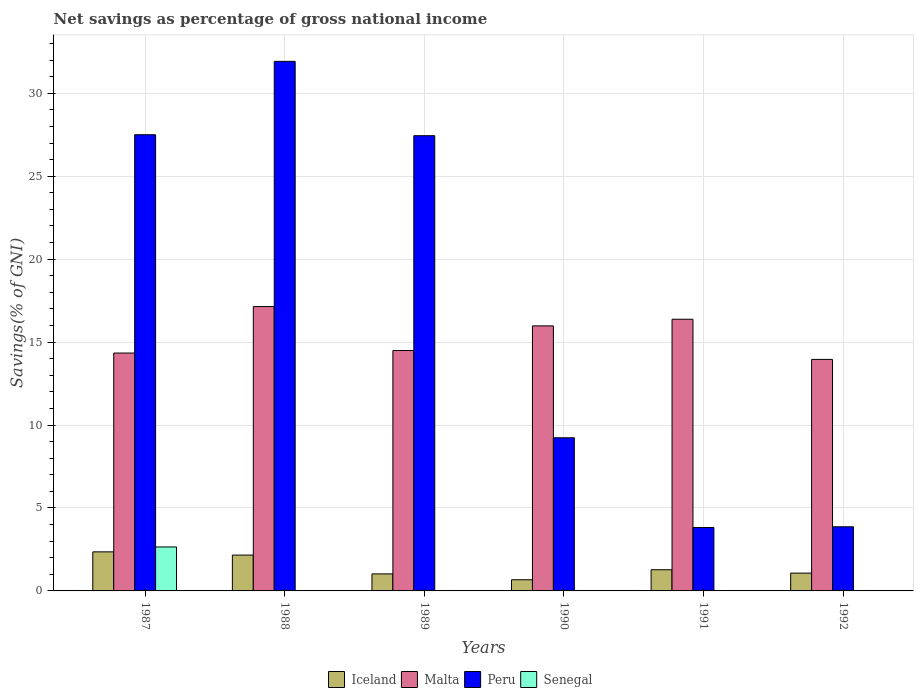How many different coloured bars are there?
Your response must be concise. 4. How many groups of bars are there?
Offer a terse response. 6. Are the number of bars per tick equal to the number of legend labels?
Make the answer very short. No. Are the number of bars on each tick of the X-axis equal?
Offer a very short reply. No. How many bars are there on the 4th tick from the left?
Offer a very short reply. 3. How many bars are there on the 5th tick from the right?
Your answer should be very brief. 3. What is the label of the 3rd group of bars from the left?
Offer a terse response. 1989. What is the total savings in Iceland in 1990?
Your response must be concise. 0.67. Across all years, what is the maximum total savings in Senegal?
Keep it short and to the point. 2.65. Across all years, what is the minimum total savings in Peru?
Your answer should be very brief. 3.82. What is the total total savings in Senegal in the graph?
Offer a terse response. 2.65. What is the difference between the total savings in Malta in 1989 and that in 1990?
Provide a succinct answer. -1.49. What is the difference between the total savings in Senegal in 1988 and the total savings in Peru in 1992?
Offer a very short reply. -3.87. What is the average total savings in Iceland per year?
Give a very brief answer. 1.43. In the year 1988, what is the difference between the total savings in Iceland and total savings in Peru?
Provide a succinct answer. -29.76. What is the ratio of the total savings in Malta in 1987 to that in 1989?
Your answer should be very brief. 0.99. Is the difference between the total savings in Iceland in 1990 and 1992 greater than the difference between the total savings in Peru in 1990 and 1992?
Provide a succinct answer. No. What is the difference between the highest and the second highest total savings in Peru?
Keep it short and to the point. 4.42. What is the difference between the highest and the lowest total savings in Malta?
Your response must be concise. 3.19. Is the sum of the total savings in Malta in 1990 and 1992 greater than the maximum total savings in Senegal across all years?
Make the answer very short. Yes. How many bars are there?
Offer a terse response. 19. What is the difference between two consecutive major ticks on the Y-axis?
Your answer should be very brief. 5. Are the values on the major ticks of Y-axis written in scientific E-notation?
Your response must be concise. No. Does the graph contain any zero values?
Offer a very short reply. Yes. How many legend labels are there?
Keep it short and to the point. 4. What is the title of the graph?
Your answer should be compact. Net savings as percentage of gross national income. Does "Guatemala" appear as one of the legend labels in the graph?
Your answer should be compact. No. What is the label or title of the X-axis?
Ensure brevity in your answer.  Years. What is the label or title of the Y-axis?
Make the answer very short. Savings(% of GNI). What is the Savings(% of GNI) in Iceland in 1987?
Your response must be concise. 2.36. What is the Savings(% of GNI) in Malta in 1987?
Your answer should be compact. 14.34. What is the Savings(% of GNI) in Peru in 1987?
Provide a short and direct response. 27.5. What is the Savings(% of GNI) in Senegal in 1987?
Provide a short and direct response. 2.65. What is the Savings(% of GNI) in Iceland in 1988?
Make the answer very short. 2.16. What is the Savings(% of GNI) of Malta in 1988?
Your response must be concise. 17.14. What is the Savings(% of GNI) in Peru in 1988?
Ensure brevity in your answer.  31.92. What is the Savings(% of GNI) in Senegal in 1988?
Provide a succinct answer. 0. What is the Savings(% of GNI) in Iceland in 1989?
Your answer should be very brief. 1.03. What is the Savings(% of GNI) in Malta in 1989?
Your answer should be compact. 14.49. What is the Savings(% of GNI) of Peru in 1989?
Provide a short and direct response. 27.44. What is the Savings(% of GNI) of Senegal in 1989?
Provide a succinct answer. 0. What is the Savings(% of GNI) of Iceland in 1990?
Make the answer very short. 0.67. What is the Savings(% of GNI) of Malta in 1990?
Your answer should be very brief. 15.98. What is the Savings(% of GNI) of Peru in 1990?
Ensure brevity in your answer.  9.23. What is the Savings(% of GNI) in Iceland in 1991?
Offer a terse response. 1.28. What is the Savings(% of GNI) of Malta in 1991?
Provide a succinct answer. 16.38. What is the Savings(% of GNI) in Peru in 1991?
Your answer should be compact. 3.82. What is the Savings(% of GNI) in Senegal in 1991?
Your answer should be compact. 0. What is the Savings(% of GNI) in Iceland in 1992?
Ensure brevity in your answer.  1.07. What is the Savings(% of GNI) of Malta in 1992?
Ensure brevity in your answer.  13.96. What is the Savings(% of GNI) in Peru in 1992?
Make the answer very short. 3.87. Across all years, what is the maximum Savings(% of GNI) in Iceland?
Provide a succinct answer. 2.36. Across all years, what is the maximum Savings(% of GNI) of Malta?
Make the answer very short. 17.14. Across all years, what is the maximum Savings(% of GNI) of Peru?
Your answer should be very brief. 31.92. Across all years, what is the maximum Savings(% of GNI) of Senegal?
Offer a very short reply. 2.65. Across all years, what is the minimum Savings(% of GNI) in Iceland?
Your response must be concise. 0.67. Across all years, what is the minimum Savings(% of GNI) in Malta?
Give a very brief answer. 13.96. Across all years, what is the minimum Savings(% of GNI) in Peru?
Ensure brevity in your answer.  3.82. What is the total Savings(% of GNI) in Iceland in the graph?
Provide a succinct answer. 8.57. What is the total Savings(% of GNI) of Malta in the graph?
Offer a very short reply. 92.29. What is the total Savings(% of GNI) in Peru in the graph?
Keep it short and to the point. 103.79. What is the total Savings(% of GNI) in Senegal in the graph?
Your response must be concise. 2.65. What is the difference between the Savings(% of GNI) of Iceland in 1987 and that in 1988?
Give a very brief answer. 0.2. What is the difference between the Savings(% of GNI) of Malta in 1987 and that in 1988?
Your answer should be very brief. -2.8. What is the difference between the Savings(% of GNI) of Peru in 1987 and that in 1988?
Offer a very short reply. -4.42. What is the difference between the Savings(% of GNI) of Iceland in 1987 and that in 1989?
Your answer should be compact. 1.33. What is the difference between the Savings(% of GNI) of Malta in 1987 and that in 1989?
Offer a very short reply. -0.15. What is the difference between the Savings(% of GNI) in Peru in 1987 and that in 1989?
Offer a very short reply. 0.06. What is the difference between the Savings(% of GNI) of Iceland in 1987 and that in 1990?
Offer a very short reply. 1.68. What is the difference between the Savings(% of GNI) in Malta in 1987 and that in 1990?
Your answer should be compact. -1.64. What is the difference between the Savings(% of GNI) in Peru in 1987 and that in 1990?
Your answer should be compact. 18.27. What is the difference between the Savings(% of GNI) in Iceland in 1987 and that in 1991?
Your response must be concise. 1.08. What is the difference between the Savings(% of GNI) of Malta in 1987 and that in 1991?
Provide a succinct answer. -2.04. What is the difference between the Savings(% of GNI) of Peru in 1987 and that in 1991?
Your response must be concise. 23.68. What is the difference between the Savings(% of GNI) in Iceland in 1987 and that in 1992?
Offer a terse response. 1.28. What is the difference between the Savings(% of GNI) in Malta in 1987 and that in 1992?
Offer a very short reply. 0.38. What is the difference between the Savings(% of GNI) of Peru in 1987 and that in 1992?
Keep it short and to the point. 23.64. What is the difference between the Savings(% of GNI) in Iceland in 1988 and that in 1989?
Offer a terse response. 1.13. What is the difference between the Savings(% of GNI) in Malta in 1988 and that in 1989?
Your response must be concise. 2.65. What is the difference between the Savings(% of GNI) of Peru in 1988 and that in 1989?
Offer a terse response. 4.48. What is the difference between the Savings(% of GNI) in Iceland in 1988 and that in 1990?
Make the answer very short. 1.49. What is the difference between the Savings(% of GNI) in Malta in 1988 and that in 1990?
Offer a terse response. 1.17. What is the difference between the Savings(% of GNI) of Peru in 1988 and that in 1990?
Your answer should be compact. 22.69. What is the difference between the Savings(% of GNI) in Iceland in 1988 and that in 1991?
Your answer should be compact. 0.88. What is the difference between the Savings(% of GNI) in Malta in 1988 and that in 1991?
Keep it short and to the point. 0.76. What is the difference between the Savings(% of GNI) of Peru in 1988 and that in 1991?
Ensure brevity in your answer.  28.1. What is the difference between the Savings(% of GNI) of Iceland in 1988 and that in 1992?
Make the answer very short. 1.09. What is the difference between the Savings(% of GNI) of Malta in 1988 and that in 1992?
Give a very brief answer. 3.19. What is the difference between the Savings(% of GNI) in Peru in 1988 and that in 1992?
Give a very brief answer. 28.06. What is the difference between the Savings(% of GNI) of Iceland in 1989 and that in 1990?
Make the answer very short. 0.35. What is the difference between the Savings(% of GNI) of Malta in 1989 and that in 1990?
Ensure brevity in your answer.  -1.49. What is the difference between the Savings(% of GNI) of Peru in 1989 and that in 1990?
Your answer should be compact. 18.21. What is the difference between the Savings(% of GNI) in Iceland in 1989 and that in 1991?
Your answer should be compact. -0.25. What is the difference between the Savings(% of GNI) of Malta in 1989 and that in 1991?
Your answer should be very brief. -1.89. What is the difference between the Savings(% of GNI) of Peru in 1989 and that in 1991?
Offer a very short reply. 23.62. What is the difference between the Savings(% of GNI) of Iceland in 1989 and that in 1992?
Your answer should be compact. -0.05. What is the difference between the Savings(% of GNI) in Malta in 1989 and that in 1992?
Provide a succinct answer. 0.54. What is the difference between the Savings(% of GNI) of Peru in 1989 and that in 1992?
Give a very brief answer. 23.58. What is the difference between the Savings(% of GNI) in Iceland in 1990 and that in 1991?
Make the answer very short. -0.6. What is the difference between the Savings(% of GNI) in Malta in 1990 and that in 1991?
Provide a short and direct response. -0.4. What is the difference between the Savings(% of GNI) of Peru in 1990 and that in 1991?
Offer a terse response. 5.41. What is the difference between the Savings(% of GNI) in Iceland in 1990 and that in 1992?
Give a very brief answer. -0.4. What is the difference between the Savings(% of GNI) in Malta in 1990 and that in 1992?
Ensure brevity in your answer.  2.02. What is the difference between the Savings(% of GNI) of Peru in 1990 and that in 1992?
Make the answer very short. 5.36. What is the difference between the Savings(% of GNI) in Iceland in 1991 and that in 1992?
Offer a terse response. 0.2. What is the difference between the Savings(% of GNI) of Malta in 1991 and that in 1992?
Offer a terse response. 2.42. What is the difference between the Savings(% of GNI) of Peru in 1991 and that in 1992?
Ensure brevity in your answer.  -0.04. What is the difference between the Savings(% of GNI) of Iceland in 1987 and the Savings(% of GNI) of Malta in 1988?
Offer a very short reply. -14.79. What is the difference between the Savings(% of GNI) in Iceland in 1987 and the Savings(% of GNI) in Peru in 1988?
Provide a succinct answer. -29.57. What is the difference between the Savings(% of GNI) in Malta in 1987 and the Savings(% of GNI) in Peru in 1988?
Your answer should be compact. -17.58. What is the difference between the Savings(% of GNI) in Iceland in 1987 and the Savings(% of GNI) in Malta in 1989?
Your answer should be compact. -12.14. What is the difference between the Savings(% of GNI) in Iceland in 1987 and the Savings(% of GNI) in Peru in 1989?
Offer a terse response. -25.09. What is the difference between the Savings(% of GNI) in Malta in 1987 and the Savings(% of GNI) in Peru in 1989?
Your answer should be very brief. -13.1. What is the difference between the Savings(% of GNI) of Iceland in 1987 and the Savings(% of GNI) of Malta in 1990?
Provide a succinct answer. -13.62. What is the difference between the Savings(% of GNI) of Iceland in 1987 and the Savings(% of GNI) of Peru in 1990?
Your answer should be very brief. -6.88. What is the difference between the Savings(% of GNI) in Malta in 1987 and the Savings(% of GNI) in Peru in 1990?
Provide a succinct answer. 5.11. What is the difference between the Savings(% of GNI) in Iceland in 1987 and the Savings(% of GNI) in Malta in 1991?
Offer a very short reply. -14.02. What is the difference between the Savings(% of GNI) of Iceland in 1987 and the Savings(% of GNI) of Peru in 1991?
Offer a terse response. -1.47. What is the difference between the Savings(% of GNI) of Malta in 1987 and the Savings(% of GNI) of Peru in 1991?
Your answer should be very brief. 10.52. What is the difference between the Savings(% of GNI) in Iceland in 1987 and the Savings(% of GNI) in Malta in 1992?
Make the answer very short. -11.6. What is the difference between the Savings(% of GNI) of Iceland in 1987 and the Savings(% of GNI) of Peru in 1992?
Your answer should be compact. -1.51. What is the difference between the Savings(% of GNI) in Malta in 1987 and the Savings(% of GNI) in Peru in 1992?
Offer a very short reply. 10.47. What is the difference between the Savings(% of GNI) in Iceland in 1988 and the Savings(% of GNI) in Malta in 1989?
Your response must be concise. -12.33. What is the difference between the Savings(% of GNI) of Iceland in 1988 and the Savings(% of GNI) of Peru in 1989?
Provide a succinct answer. -25.28. What is the difference between the Savings(% of GNI) in Malta in 1988 and the Savings(% of GNI) in Peru in 1989?
Offer a terse response. -10.3. What is the difference between the Savings(% of GNI) in Iceland in 1988 and the Savings(% of GNI) in Malta in 1990?
Your answer should be very brief. -13.82. What is the difference between the Savings(% of GNI) of Iceland in 1988 and the Savings(% of GNI) of Peru in 1990?
Provide a succinct answer. -7.07. What is the difference between the Savings(% of GNI) of Malta in 1988 and the Savings(% of GNI) of Peru in 1990?
Offer a terse response. 7.91. What is the difference between the Savings(% of GNI) of Iceland in 1988 and the Savings(% of GNI) of Malta in 1991?
Give a very brief answer. -14.22. What is the difference between the Savings(% of GNI) of Iceland in 1988 and the Savings(% of GNI) of Peru in 1991?
Ensure brevity in your answer.  -1.66. What is the difference between the Savings(% of GNI) in Malta in 1988 and the Savings(% of GNI) in Peru in 1991?
Your answer should be very brief. 13.32. What is the difference between the Savings(% of GNI) in Iceland in 1988 and the Savings(% of GNI) in Malta in 1992?
Keep it short and to the point. -11.8. What is the difference between the Savings(% of GNI) of Iceland in 1988 and the Savings(% of GNI) of Peru in 1992?
Give a very brief answer. -1.71. What is the difference between the Savings(% of GNI) in Malta in 1988 and the Savings(% of GNI) in Peru in 1992?
Provide a short and direct response. 13.28. What is the difference between the Savings(% of GNI) of Iceland in 1989 and the Savings(% of GNI) of Malta in 1990?
Your answer should be very brief. -14.95. What is the difference between the Savings(% of GNI) in Iceland in 1989 and the Savings(% of GNI) in Peru in 1990?
Your answer should be compact. -8.2. What is the difference between the Savings(% of GNI) of Malta in 1989 and the Savings(% of GNI) of Peru in 1990?
Keep it short and to the point. 5.26. What is the difference between the Savings(% of GNI) in Iceland in 1989 and the Savings(% of GNI) in Malta in 1991?
Your answer should be compact. -15.35. What is the difference between the Savings(% of GNI) in Iceland in 1989 and the Savings(% of GNI) in Peru in 1991?
Provide a short and direct response. -2.8. What is the difference between the Savings(% of GNI) in Malta in 1989 and the Savings(% of GNI) in Peru in 1991?
Provide a succinct answer. 10.67. What is the difference between the Savings(% of GNI) of Iceland in 1989 and the Savings(% of GNI) of Malta in 1992?
Offer a terse response. -12.93. What is the difference between the Savings(% of GNI) in Iceland in 1989 and the Savings(% of GNI) in Peru in 1992?
Give a very brief answer. -2.84. What is the difference between the Savings(% of GNI) in Malta in 1989 and the Savings(% of GNI) in Peru in 1992?
Provide a succinct answer. 10.63. What is the difference between the Savings(% of GNI) of Iceland in 1990 and the Savings(% of GNI) of Malta in 1991?
Make the answer very short. -15.71. What is the difference between the Savings(% of GNI) in Iceland in 1990 and the Savings(% of GNI) in Peru in 1991?
Give a very brief answer. -3.15. What is the difference between the Savings(% of GNI) in Malta in 1990 and the Savings(% of GNI) in Peru in 1991?
Offer a very short reply. 12.15. What is the difference between the Savings(% of GNI) in Iceland in 1990 and the Savings(% of GNI) in Malta in 1992?
Offer a very short reply. -13.28. What is the difference between the Savings(% of GNI) in Iceland in 1990 and the Savings(% of GNI) in Peru in 1992?
Your answer should be very brief. -3.19. What is the difference between the Savings(% of GNI) in Malta in 1990 and the Savings(% of GNI) in Peru in 1992?
Your response must be concise. 12.11. What is the difference between the Savings(% of GNI) in Iceland in 1991 and the Savings(% of GNI) in Malta in 1992?
Ensure brevity in your answer.  -12.68. What is the difference between the Savings(% of GNI) of Iceland in 1991 and the Savings(% of GNI) of Peru in 1992?
Offer a very short reply. -2.59. What is the difference between the Savings(% of GNI) in Malta in 1991 and the Savings(% of GNI) in Peru in 1992?
Offer a terse response. 12.51. What is the average Savings(% of GNI) in Iceland per year?
Ensure brevity in your answer.  1.43. What is the average Savings(% of GNI) of Malta per year?
Your answer should be compact. 15.38. What is the average Savings(% of GNI) of Peru per year?
Keep it short and to the point. 17.3. What is the average Savings(% of GNI) of Senegal per year?
Make the answer very short. 0.44. In the year 1987, what is the difference between the Savings(% of GNI) of Iceland and Savings(% of GNI) of Malta?
Make the answer very short. -11.98. In the year 1987, what is the difference between the Savings(% of GNI) of Iceland and Savings(% of GNI) of Peru?
Your answer should be very brief. -25.15. In the year 1987, what is the difference between the Savings(% of GNI) in Iceland and Savings(% of GNI) in Senegal?
Ensure brevity in your answer.  -0.29. In the year 1987, what is the difference between the Savings(% of GNI) of Malta and Savings(% of GNI) of Peru?
Provide a short and direct response. -13.16. In the year 1987, what is the difference between the Savings(% of GNI) of Malta and Savings(% of GNI) of Senegal?
Your answer should be compact. 11.69. In the year 1987, what is the difference between the Savings(% of GNI) in Peru and Savings(% of GNI) in Senegal?
Make the answer very short. 24.85. In the year 1988, what is the difference between the Savings(% of GNI) in Iceland and Savings(% of GNI) in Malta?
Your answer should be very brief. -14.98. In the year 1988, what is the difference between the Savings(% of GNI) in Iceland and Savings(% of GNI) in Peru?
Ensure brevity in your answer.  -29.76. In the year 1988, what is the difference between the Savings(% of GNI) of Malta and Savings(% of GNI) of Peru?
Keep it short and to the point. -14.78. In the year 1989, what is the difference between the Savings(% of GNI) in Iceland and Savings(% of GNI) in Malta?
Provide a succinct answer. -13.47. In the year 1989, what is the difference between the Savings(% of GNI) in Iceland and Savings(% of GNI) in Peru?
Your answer should be compact. -26.42. In the year 1989, what is the difference between the Savings(% of GNI) of Malta and Savings(% of GNI) of Peru?
Make the answer very short. -12.95. In the year 1990, what is the difference between the Savings(% of GNI) in Iceland and Savings(% of GNI) in Malta?
Ensure brevity in your answer.  -15.3. In the year 1990, what is the difference between the Savings(% of GNI) in Iceland and Savings(% of GNI) in Peru?
Provide a short and direct response. -8.56. In the year 1990, what is the difference between the Savings(% of GNI) in Malta and Savings(% of GNI) in Peru?
Make the answer very short. 6.75. In the year 1991, what is the difference between the Savings(% of GNI) in Iceland and Savings(% of GNI) in Malta?
Provide a short and direct response. -15.1. In the year 1991, what is the difference between the Savings(% of GNI) of Iceland and Savings(% of GNI) of Peru?
Keep it short and to the point. -2.55. In the year 1991, what is the difference between the Savings(% of GNI) in Malta and Savings(% of GNI) in Peru?
Ensure brevity in your answer.  12.55. In the year 1992, what is the difference between the Savings(% of GNI) in Iceland and Savings(% of GNI) in Malta?
Your answer should be compact. -12.88. In the year 1992, what is the difference between the Savings(% of GNI) in Iceland and Savings(% of GNI) in Peru?
Give a very brief answer. -2.79. In the year 1992, what is the difference between the Savings(% of GNI) in Malta and Savings(% of GNI) in Peru?
Give a very brief answer. 10.09. What is the ratio of the Savings(% of GNI) in Iceland in 1987 to that in 1988?
Provide a short and direct response. 1.09. What is the ratio of the Savings(% of GNI) in Malta in 1987 to that in 1988?
Your answer should be very brief. 0.84. What is the ratio of the Savings(% of GNI) of Peru in 1987 to that in 1988?
Your response must be concise. 0.86. What is the ratio of the Savings(% of GNI) in Iceland in 1987 to that in 1989?
Provide a succinct answer. 2.3. What is the ratio of the Savings(% of GNI) in Malta in 1987 to that in 1989?
Provide a succinct answer. 0.99. What is the ratio of the Savings(% of GNI) of Peru in 1987 to that in 1989?
Ensure brevity in your answer.  1. What is the ratio of the Savings(% of GNI) of Iceland in 1987 to that in 1990?
Offer a terse response. 3.5. What is the ratio of the Savings(% of GNI) in Malta in 1987 to that in 1990?
Keep it short and to the point. 0.9. What is the ratio of the Savings(% of GNI) of Peru in 1987 to that in 1990?
Provide a succinct answer. 2.98. What is the ratio of the Savings(% of GNI) of Iceland in 1987 to that in 1991?
Make the answer very short. 1.84. What is the ratio of the Savings(% of GNI) of Malta in 1987 to that in 1991?
Offer a terse response. 0.88. What is the ratio of the Savings(% of GNI) in Peru in 1987 to that in 1991?
Offer a terse response. 7.19. What is the ratio of the Savings(% of GNI) in Iceland in 1987 to that in 1992?
Your response must be concise. 2.2. What is the ratio of the Savings(% of GNI) of Malta in 1987 to that in 1992?
Your answer should be very brief. 1.03. What is the ratio of the Savings(% of GNI) of Peru in 1987 to that in 1992?
Provide a succinct answer. 7.11. What is the ratio of the Savings(% of GNI) in Iceland in 1988 to that in 1989?
Offer a very short reply. 2.1. What is the ratio of the Savings(% of GNI) of Malta in 1988 to that in 1989?
Give a very brief answer. 1.18. What is the ratio of the Savings(% of GNI) in Peru in 1988 to that in 1989?
Your answer should be very brief. 1.16. What is the ratio of the Savings(% of GNI) of Iceland in 1988 to that in 1990?
Offer a terse response. 3.21. What is the ratio of the Savings(% of GNI) of Malta in 1988 to that in 1990?
Give a very brief answer. 1.07. What is the ratio of the Savings(% of GNI) in Peru in 1988 to that in 1990?
Provide a short and direct response. 3.46. What is the ratio of the Savings(% of GNI) in Iceland in 1988 to that in 1991?
Your answer should be compact. 1.69. What is the ratio of the Savings(% of GNI) in Malta in 1988 to that in 1991?
Give a very brief answer. 1.05. What is the ratio of the Savings(% of GNI) of Peru in 1988 to that in 1991?
Offer a very short reply. 8.35. What is the ratio of the Savings(% of GNI) of Iceland in 1988 to that in 1992?
Provide a succinct answer. 2.01. What is the ratio of the Savings(% of GNI) in Malta in 1988 to that in 1992?
Offer a very short reply. 1.23. What is the ratio of the Savings(% of GNI) in Peru in 1988 to that in 1992?
Offer a terse response. 8.26. What is the ratio of the Savings(% of GNI) in Iceland in 1989 to that in 1990?
Keep it short and to the point. 1.52. What is the ratio of the Savings(% of GNI) in Malta in 1989 to that in 1990?
Your answer should be compact. 0.91. What is the ratio of the Savings(% of GNI) in Peru in 1989 to that in 1990?
Ensure brevity in your answer.  2.97. What is the ratio of the Savings(% of GNI) of Iceland in 1989 to that in 1991?
Offer a very short reply. 0.8. What is the ratio of the Savings(% of GNI) of Malta in 1989 to that in 1991?
Offer a very short reply. 0.88. What is the ratio of the Savings(% of GNI) of Peru in 1989 to that in 1991?
Offer a very short reply. 7.18. What is the ratio of the Savings(% of GNI) of Iceland in 1989 to that in 1992?
Provide a short and direct response. 0.96. What is the ratio of the Savings(% of GNI) of Peru in 1989 to that in 1992?
Provide a succinct answer. 7.1. What is the ratio of the Savings(% of GNI) of Iceland in 1990 to that in 1991?
Provide a short and direct response. 0.53. What is the ratio of the Savings(% of GNI) of Malta in 1990 to that in 1991?
Provide a short and direct response. 0.98. What is the ratio of the Savings(% of GNI) in Peru in 1990 to that in 1991?
Keep it short and to the point. 2.41. What is the ratio of the Savings(% of GNI) in Iceland in 1990 to that in 1992?
Make the answer very short. 0.63. What is the ratio of the Savings(% of GNI) of Malta in 1990 to that in 1992?
Make the answer very short. 1.14. What is the ratio of the Savings(% of GNI) of Peru in 1990 to that in 1992?
Your answer should be compact. 2.39. What is the ratio of the Savings(% of GNI) in Iceland in 1991 to that in 1992?
Keep it short and to the point. 1.19. What is the ratio of the Savings(% of GNI) in Malta in 1991 to that in 1992?
Give a very brief answer. 1.17. What is the difference between the highest and the second highest Savings(% of GNI) of Iceland?
Your answer should be very brief. 0.2. What is the difference between the highest and the second highest Savings(% of GNI) in Malta?
Give a very brief answer. 0.76. What is the difference between the highest and the second highest Savings(% of GNI) in Peru?
Your response must be concise. 4.42. What is the difference between the highest and the lowest Savings(% of GNI) of Iceland?
Provide a short and direct response. 1.68. What is the difference between the highest and the lowest Savings(% of GNI) of Malta?
Your response must be concise. 3.19. What is the difference between the highest and the lowest Savings(% of GNI) of Peru?
Give a very brief answer. 28.1. What is the difference between the highest and the lowest Savings(% of GNI) of Senegal?
Provide a succinct answer. 2.65. 